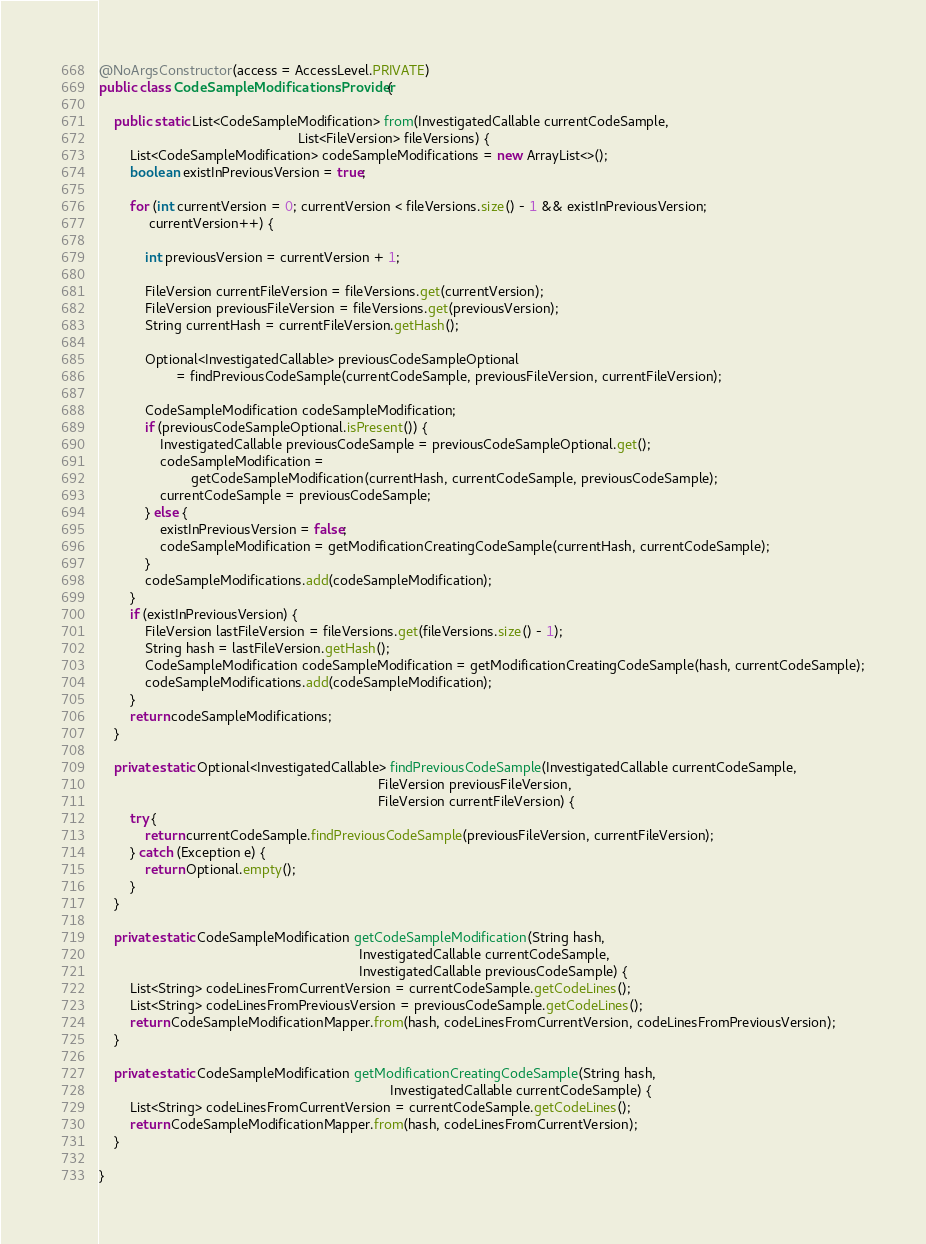Convert code to text. <code><loc_0><loc_0><loc_500><loc_500><_Java_>@NoArgsConstructor(access = AccessLevel.PRIVATE)
public class CodeSampleModificationsProvider {

    public static List<CodeSampleModification> from(InvestigatedCallable currentCodeSample,
                                                    List<FileVersion> fileVersions) {
        List<CodeSampleModification> codeSampleModifications = new ArrayList<>();
        boolean existInPreviousVersion = true;

        for (int currentVersion = 0; currentVersion < fileVersions.size() - 1 && existInPreviousVersion;
             currentVersion++) {

            int previousVersion = currentVersion + 1;

            FileVersion currentFileVersion = fileVersions.get(currentVersion);
            FileVersion previousFileVersion = fileVersions.get(previousVersion);
            String currentHash = currentFileVersion.getHash();

            Optional<InvestigatedCallable> previousCodeSampleOptional
                    = findPreviousCodeSample(currentCodeSample, previousFileVersion, currentFileVersion);

            CodeSampleModification codeSampleModification;
            if (previousCodeSampleOptional.isPresent()) {
                InvestigatedCallable previousCodeSample = previousCodeSampleOptional.get();
                codeSampleModification =
                        getCodeSampleModification(currentHash, currentCodeSample, previousCodeSample);
                currentCodeSample = previousCodeSample;
            } else {
                existInPreviousVersion = false;
                codeSampleModification = getModificationCreatingCodeSample(currentHash, currentCodeSample);
            }
            codeSampleModifications.add(codeSampleModification);
        }
        if (existInPreviousVersion) {
            FileVersion lastFileVersion = fileVersions.get(fileVersions.size() - 1);
            String hash = lastFileVersion.getHash();
            CodeSampleModification codeSampleModification = getModificationCreatingCodeSample(hash, currentCodeSample);
            codeSampleModifications.add(codeSampleModification);
        }
        return codeSampleModifications;
    }

    private static Optional<InvestigatedCallable> findPreviousCodeSample(InvestigatedCallable currentCodeSample,
                                                                         FileVersion previousFileVersion,
                                                                         FileVersion currentFileVersion) {
        try {
            return currentCodeSample.findPreviousCodeSample(previousFileVersion, currentFileVersion);
        } catch (Exception e) {
            return Optional.empty();
        }
    }

    private static CodeSampleModification getCodeSampleModification(String hash,
                                                                    InvestigatedCallable currentCodeSample,
                                                                    InvestigatedCallable previousCodeSample) {
        List<String> codeLinesFromCurrentVersion = currentCodeSample.getCodeLines();
        List<String> codeLinesFromPreviousVersion = previousCodeSample.getCodeLines();
        return CodeSampleModificationMapper.from(hash, codeLinesFromCurrentVersion, codeLinesFromPreviousVersion);
    }

    private static CodeSampleModification getModificationCreatingCodeSample(String hash,
                                                                            InvestigatedCallable currentCodeSample) {
        List<String> codeLinesFromCurrentVersion = currentCodeSample.getCodeLines();
        return CodeSampleModificationMapper.from(hash, codeLinesFromCurrentVersion);
    }

}
</code> 